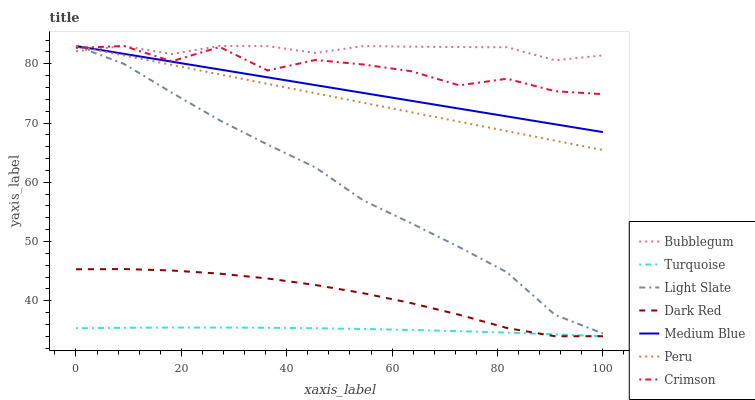Does Light Slate have the minimum area under the curve?
Answer yes or no. No. Does Light Slate have the maximum area under the curve?
Answer yes or no. No. Is Light Slate the smoothest?
Answer yes or no. No. Is Light Slate the roughest?
Answer yes or no. No. Does Light Slate have the lowest value?
Answer yes or no. No. Does Dark Red have the highest value?
Answer yes or no. No. Is Dark Red less than Light Slate?
Answer yes or no. Yes. Is Light Slate greater than Dark Red?
Answer yes or no. Yes. Does Dark Red intersect Light Slate?
Answer yes or no. No. 